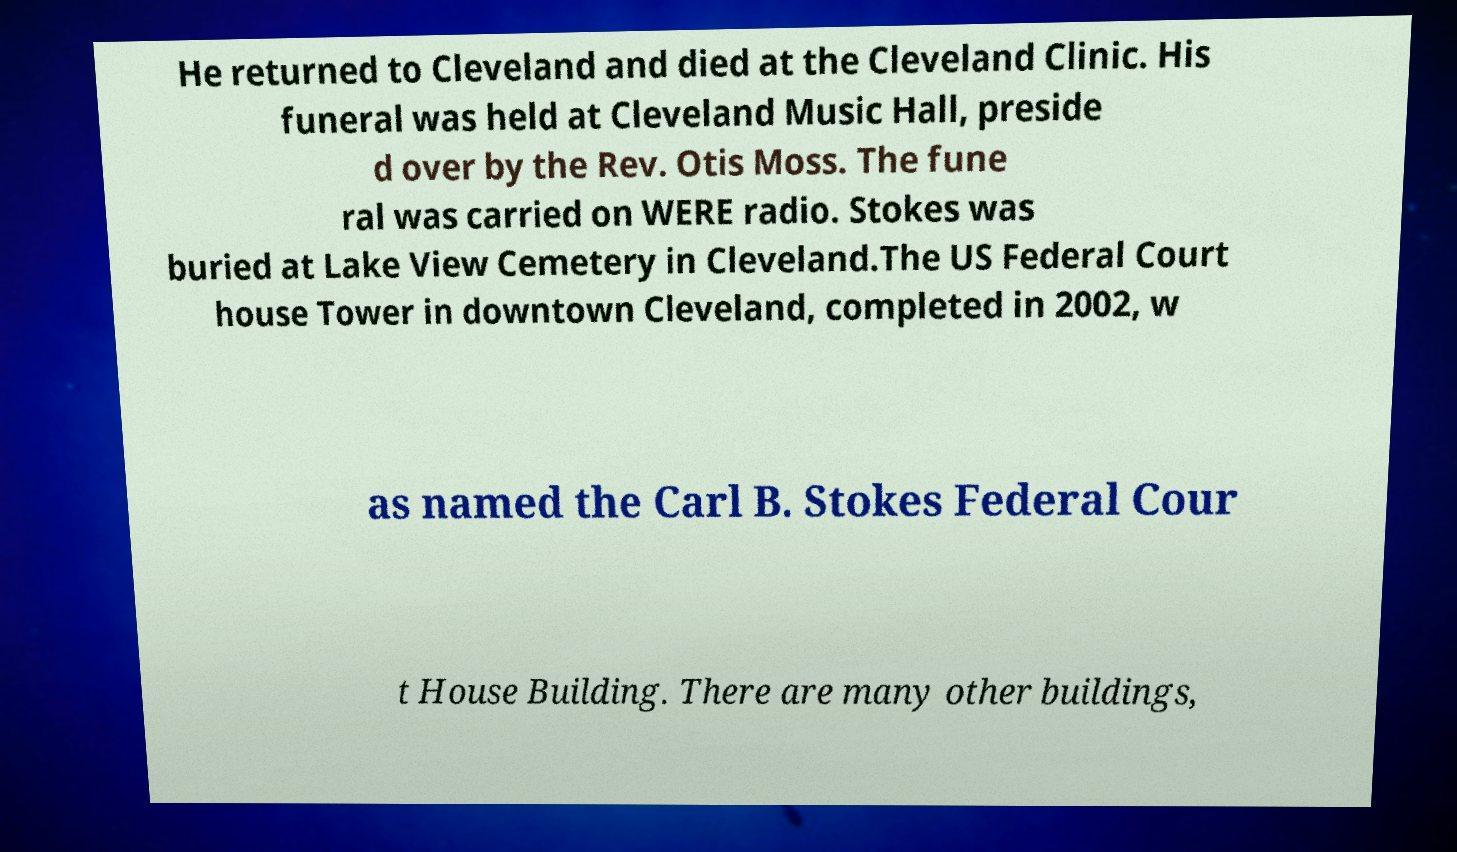Please identify and transcribe the text found in this image. He returned to Cleveland and died at the Cleveland Clinic. His funeral was held at Cleveland Music Hall, preside d over by the Rev. Otis Moss. The fune ral was carried on WERE radio. Stokes was buried at Lake View Cemetery in Cleveland.The US Federal Court house Tower in downtown Cleveland, completed in 2002, w as named the Carl B. Stokes Federal Cour t House Building. There are many other buildings, 